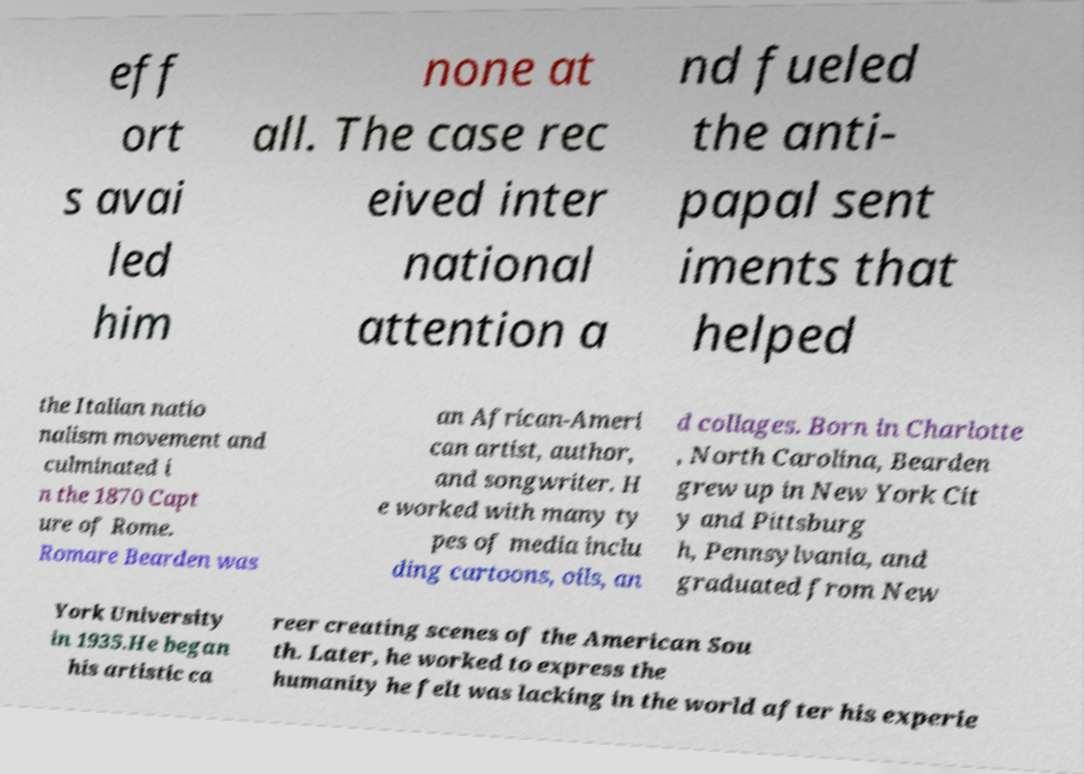Can you accurately transcribe the text from the provided image for me? eff ort s avai led him none at all. The case rec eived inter national attention a nd fueled the anti- papal sent iments that helped the Italian natio nalism movement and culminated i n the 1870 Capt ure of Rome. Romare Bearden was an African-Ameri can artist, author, and songwriter. H e worked with many ty pes of media inclu ding cartoons, oils, an d collages. Born in Charlotte , North Carolina, Bearden grew up in New York Cit y and Pittsburg h, Pennsylvania, and graduated from New York University in 1935.He began his artistic ca reer creating scenes of the American Sou th. Later, he worked to express the humanity he felt was lacking in the world after his experie 